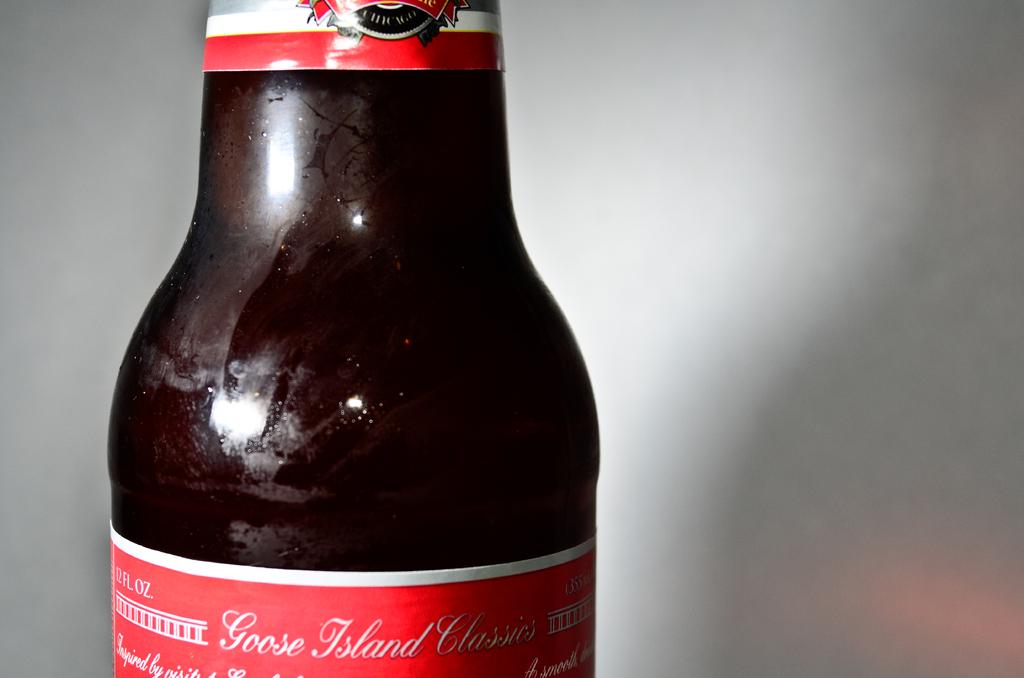What brand of beer is this?
Offer a very short reply. Unanswerable. What ounces is this beer?
Your answer should be very brief. 12. 